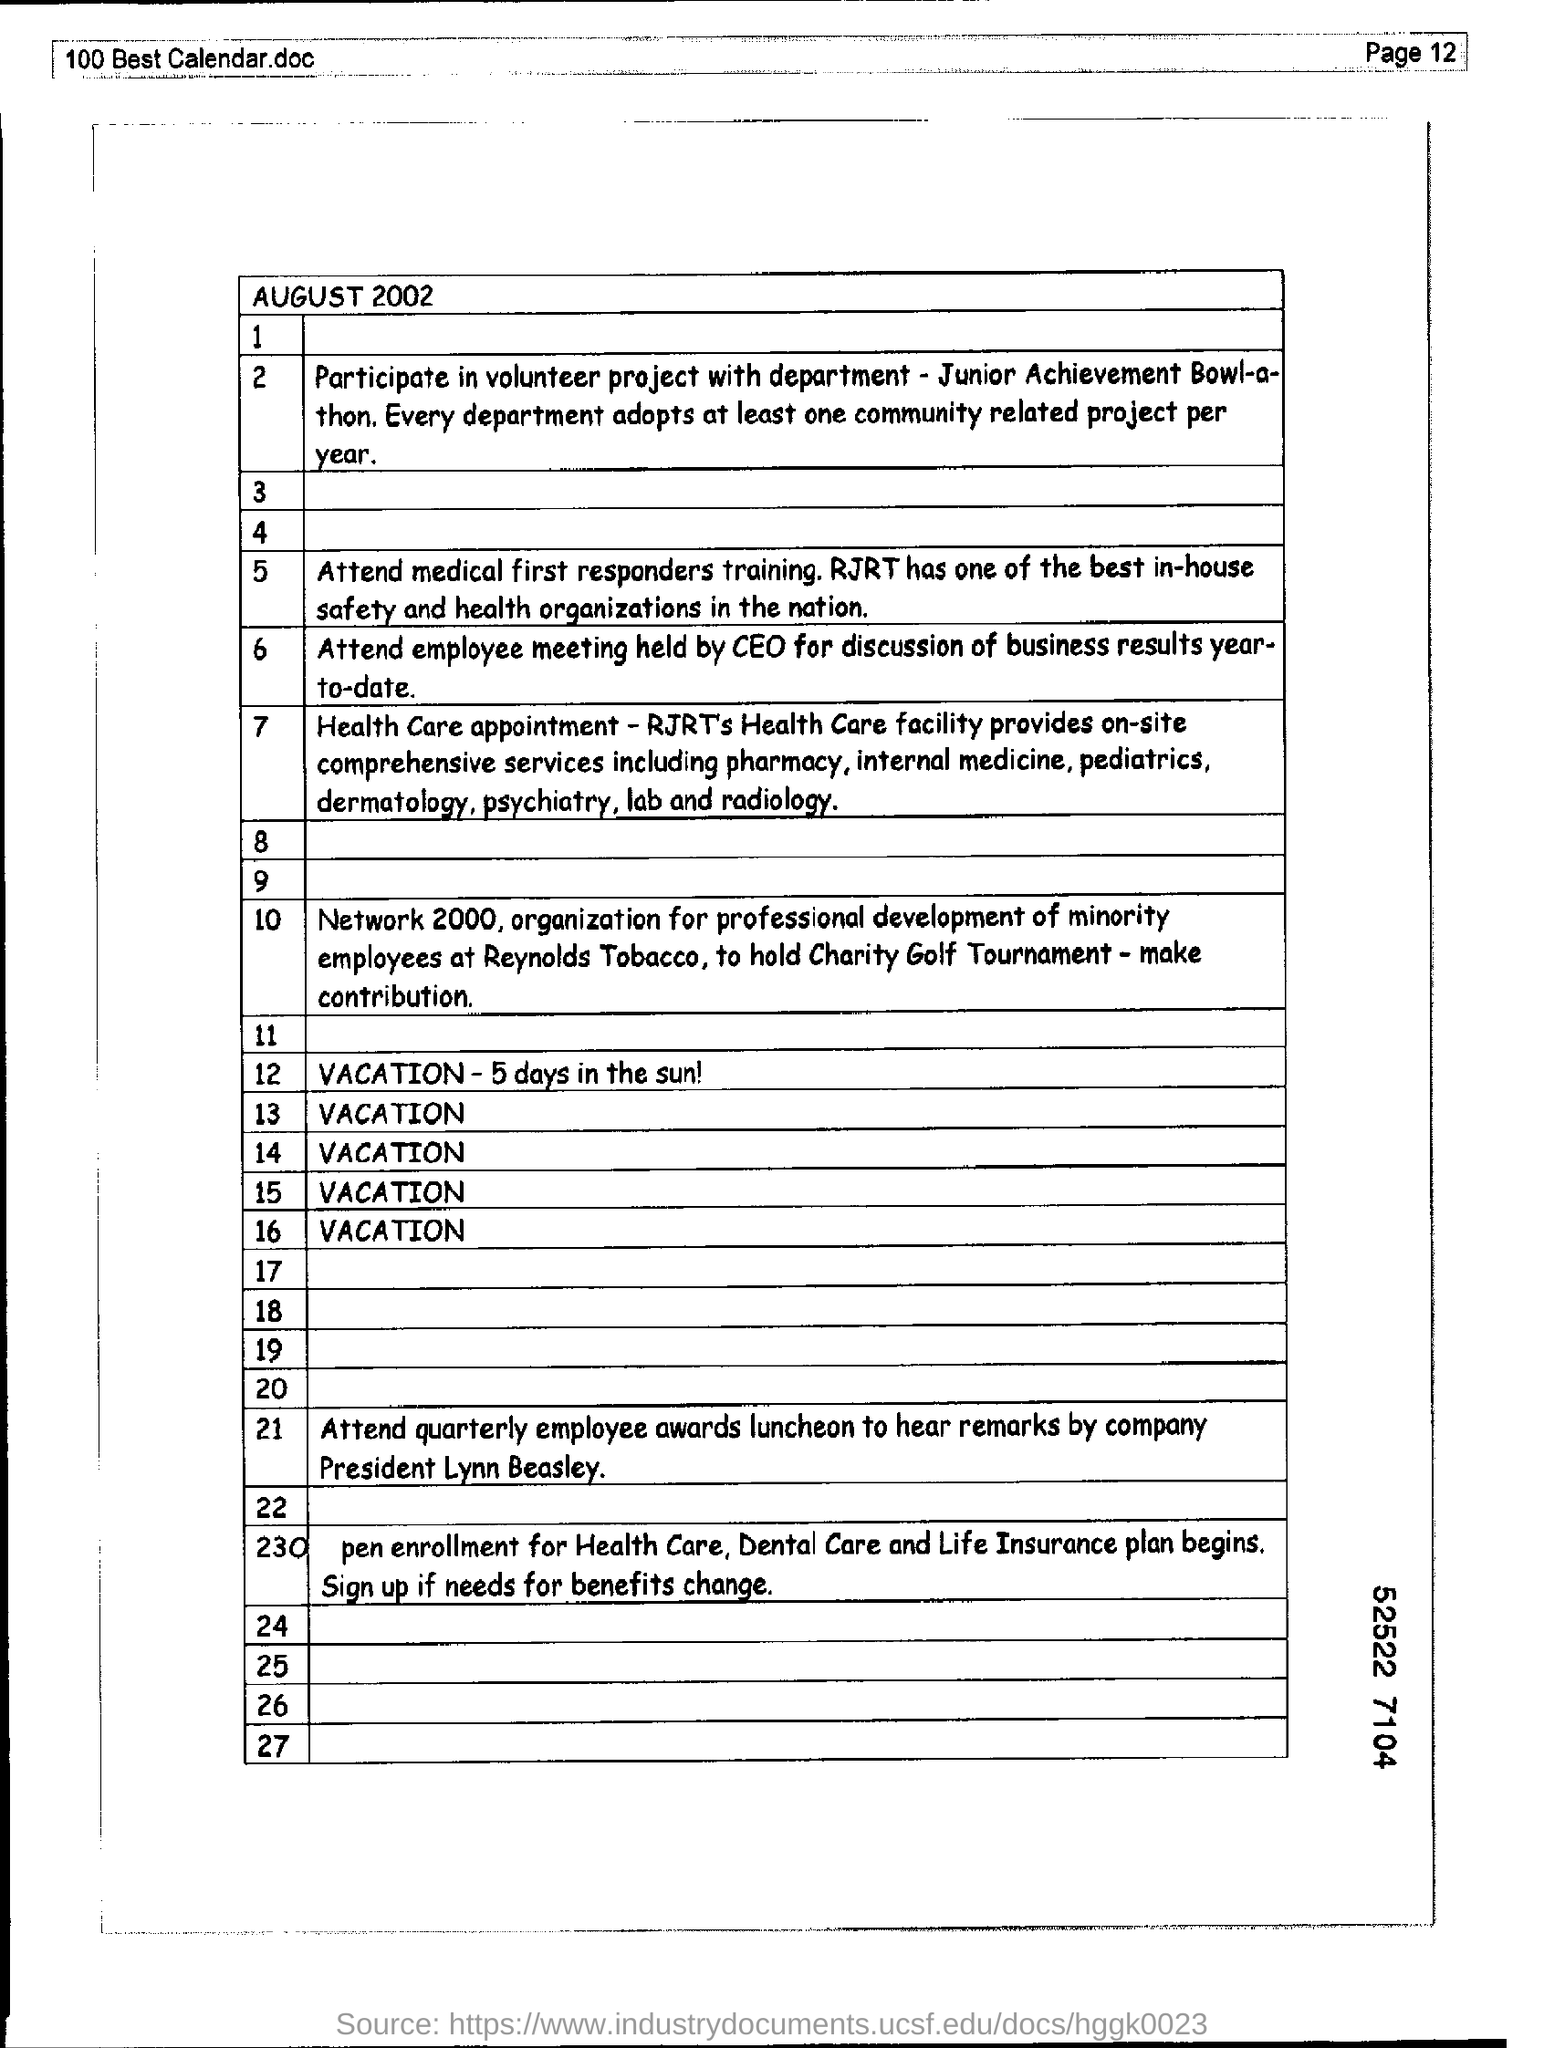Give some essential details in this illustration. RJRT is recognized as having the most outstanding in-house safety and health organizations in the country. This calendar refers to the month of August in the year 2002. 